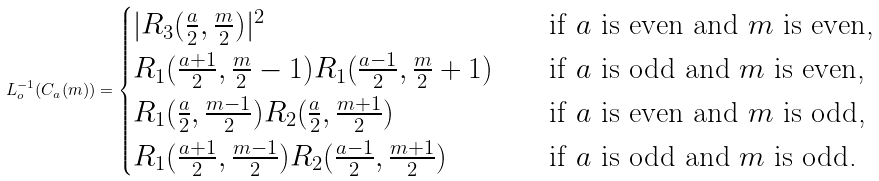Convert formula to latex. <formula><loc_0><loc_0><loc_500><loc_500>L _ { o } ^ { - 1 } ( C _ { a } ( m ) ) = \begin{cases} | R _ { 3 } ( \frac { a } { 2 } , \frac { m } { 2 } ) | ^ { 2 } \quad & \text {if\/ $a$ is even and $m$ is even,} \\ R _ { 1 } ( \frac { a + 1 } 2 , \frac { m } { 2 } - 1 ) R _ { 1 } ( \frac { a - 1 } 2 , \frac { m } { 2 } + 1 ) \quad & \text {if\/ $a$ is odd and $m$ is even,} \\ R _ { 1 } ( \frac { a } { 2 } , \frac { m - 1 } 2 ) R _ { 2 } ( \frac { a } { 2 } , \frac { m + 1 } 2 ) \quad & \text {if\/ $a$ is even and $m$ is odd,} \\ R _ { 1 } ( \frac { a + 1 } 2 , \frac { m - 1 } 2 ) R _ { 2 } ( \frac { a - 1 } 2 , \frac { m + 1 } 2 ) \quad & \text {if\/ $a$ is odd and $m$ is odd.} \end{cases}</formula> 